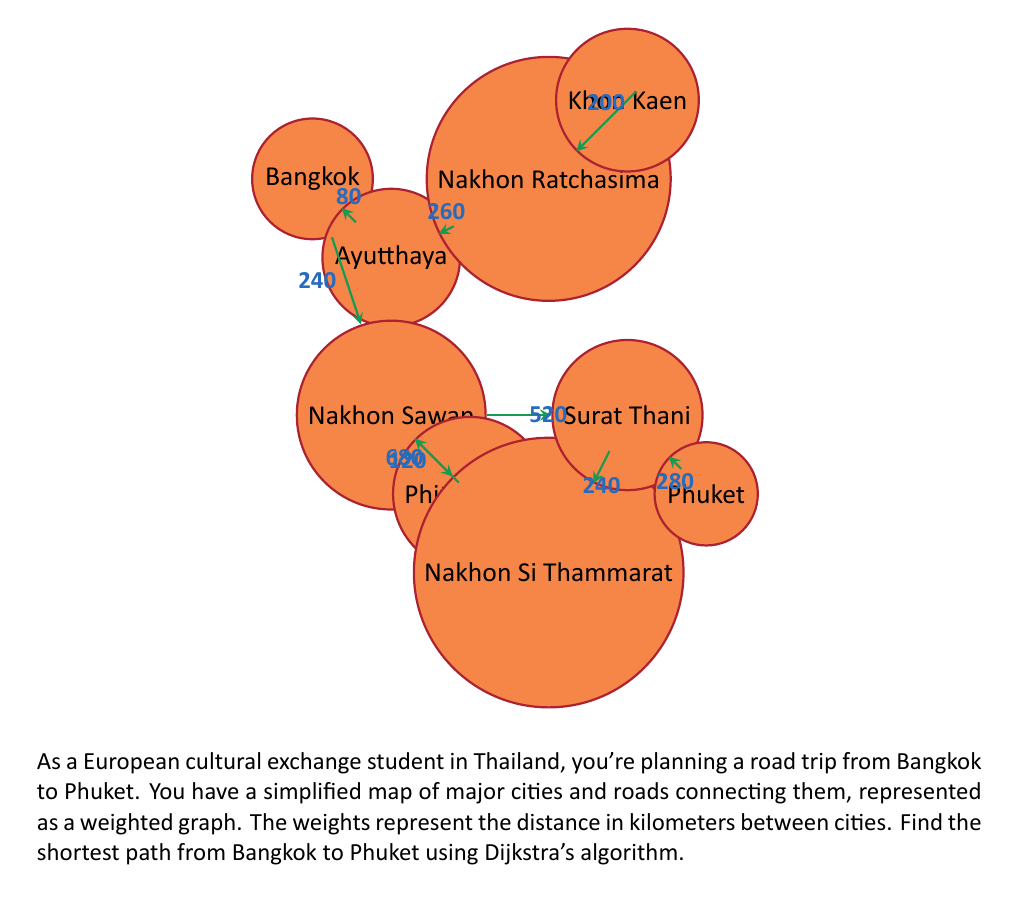What is the answer to this math problem? To solve this problem using Dijkstra's algorithm, we'll follow these steps:

1) Initialize:
   - Set distance to Bangkok (start) as 0
   - Set distances to all other cities as infinity
   - Set all cities as unvisited

2) For the current city (starting with Bangkok), consider all unvisited neighbors and calculate their tentative distances.

3) When we're done considering all neighbors of the current city, mark it as visited. A visited city will not be checked again.

4) If Phuket has been marked visited, we're done. Otherwise, select the unvisited city with the smallest tentative distance, and go back to step 2.

Let's apply the algorithm:

Start: Bangkok (0 km)
- Ayutthaya: 80 km
- Nakhon Sawan: 240 km

Visit Ayutthaya (80 km):
- Nakhon Ratchasima: 80 + 260 = 340 km

Visit Nakhon Sawan (240 km):
- Phitsanulok: 240 + 120 = 360 km
- Surat Thani: 240 + 520 = 760 km

Visit Nakhon Ratchasima (340 km):
- Khon Kaen: 340 + 200 = 540 km

Visit Phitsanulok (360 km):
- Nakhon Si Thammarat: 360 + 680 = 1040 km

Visit Surat Thani (760 km):
- Phuket: 760 + 280 = 1040 km

We've reached Phuket, so we're done. The shortest path is:

Bangkok → Nakhon Sawan → Surat Thani → Phuket

Total distance: 1040 km
Answer: Bangkok → Nakhon Sawan → Surat Thani → Phuket, 1040 km 